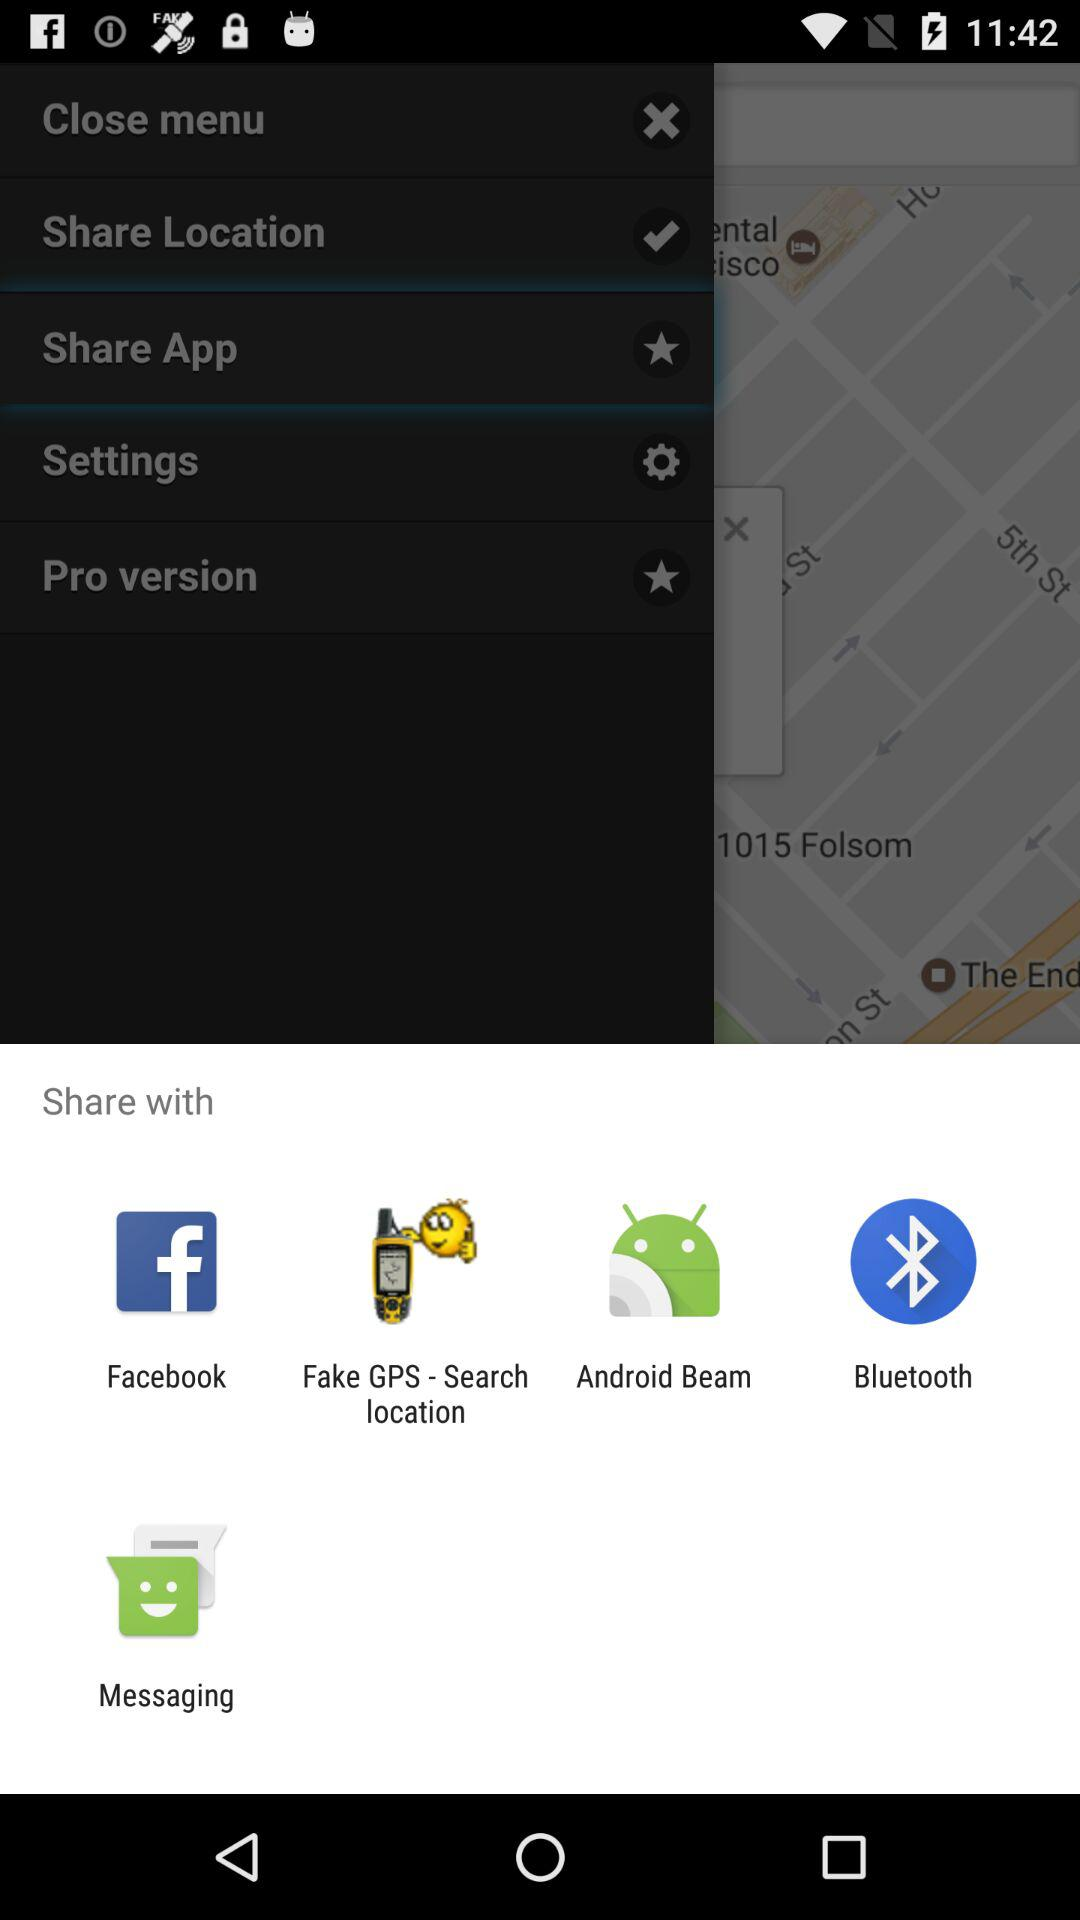What is the shared location?
When the provided information is insufficient, respond with <no answer>. <no answer> 